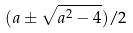Convert formula to latex. <formula><loc_0><loc_0><loc_500><loc_500>( a \pm \sqrt { a ^ { 2 } - 4 } ) / 2</formula> 